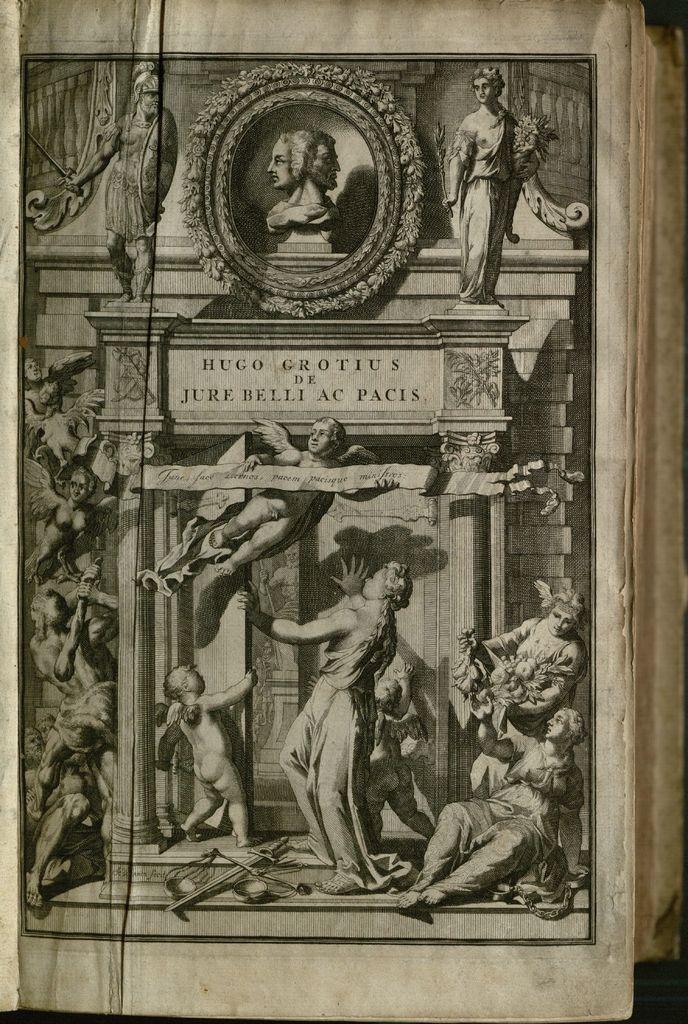In one or two sentences, can you explain what this image depicts? In this image there is a cover page of a book. On the cover page there is painting of people with wings. There are few texts over here. Here there is a statue. 